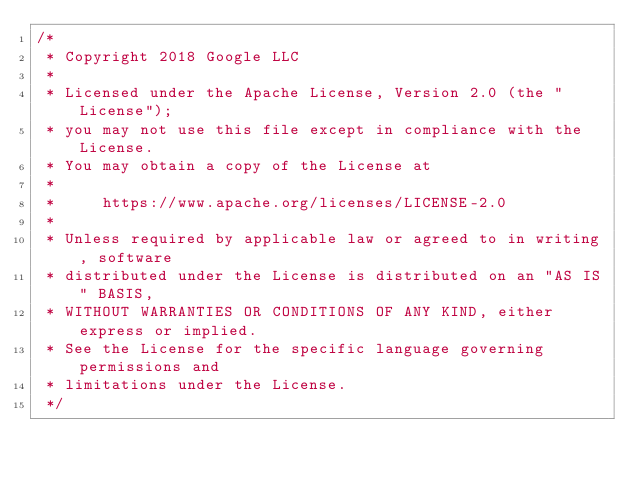Convert code to text. <code><loc_0><loc_0><loc_500><loc_500><_Kotlin_>/*
 * Copyright 2018 Google LLC
 *
 * Licensed under the Apache License, Version 2.0 (the "License");
 * you may not use this file except in compliance with the License.
 * You may obtain a copy of the License at
 *
 *     https://www.apache.org/licenses/LICENSE-2.0
 *
 * Unless required by applicable law or agreed to in writing, software
 * distributed under the License is distributed on an "AS IS" BASIS,
 * WITHOUT WARRANTIES OR CONDITIONS OF ANY KIND, either express or implied.
 * See the License for the specific language governing permissions and
 * limitations under the License.
 */
</code> 